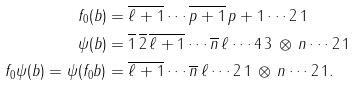Convert formula to latex. <formula><loc_0><loc_0><loc_500><loc_500>f _ { 0 } ( b ) & = \overline { \ell + 1 } \cdots \overline { p + 1 } \, p + 1 \cdots 2 \, 1 \\ \psi ( b ) & = \overline { 1 } \, \overline { 2 } \, \overline { \ell + 1 } \cdots \overline { n } \, \ell \cdots 4 \, 3 \, \otimes \, n \cdots 2 \, 1 \\ f _ { 0 } \psi ( b ) = \psi ( f _ { 0 } b ) & = \overline { \ell + 1 } \cdots \overline { n } \, \ell \cdots 2 \, 1 \, \otimes \, n \cdots 2 \, 1 .</formula> 